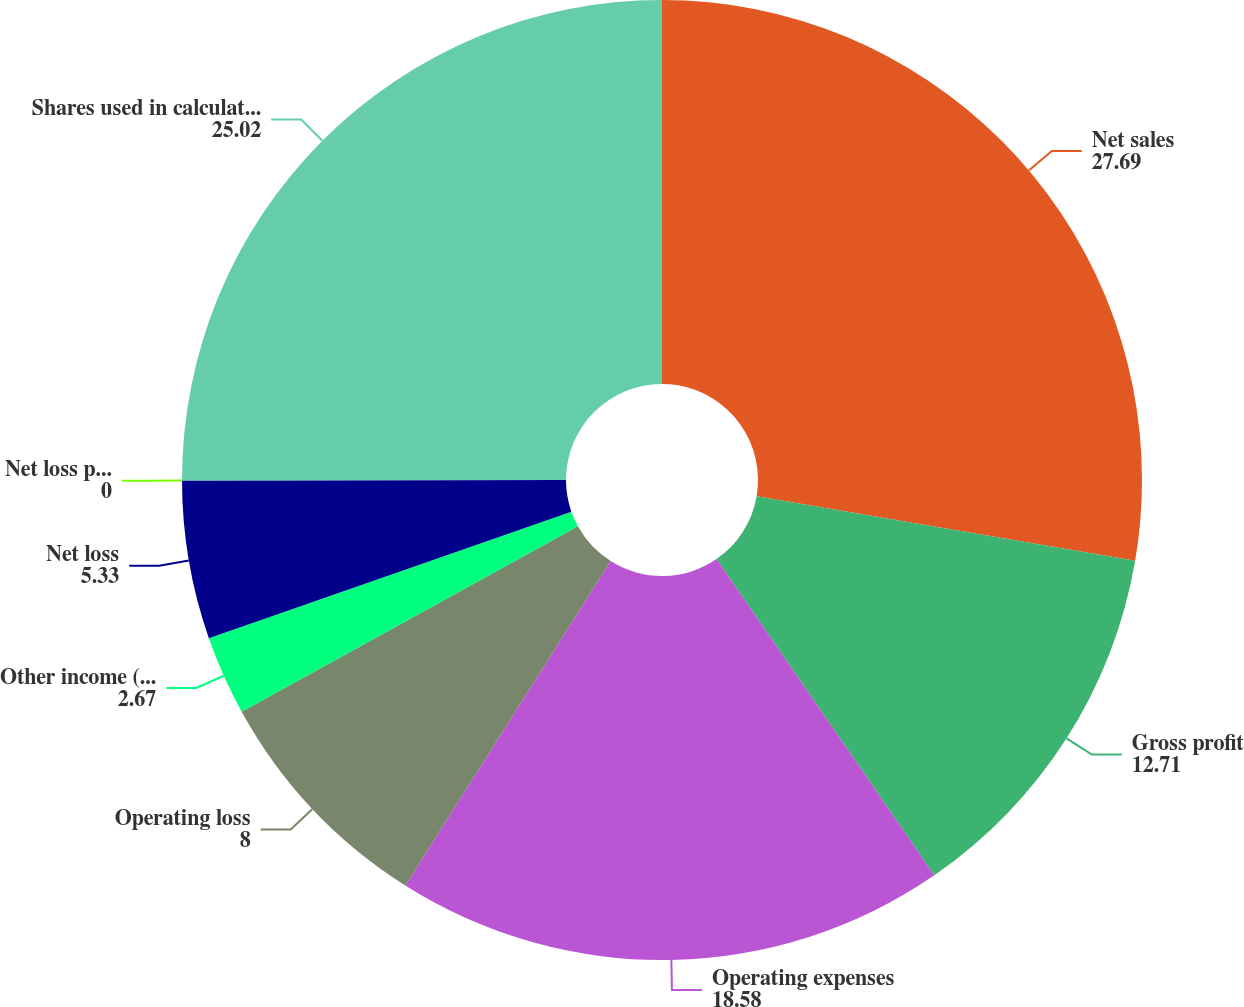<chart> <loc_0><loc_0><loc_500><loc_500><pie_chart><fcel>Net sales<fcel>Gross profit<fcel>Operating expenses<fcel>Operating loss<fcel>Other income (expense)<fcel>Net loss<fcel>Net loss per share<fcel>Shares used in calculation of<nl><fcel>27.69%<fcel>12.71%<fcel>18.58%<fcel>8.0%<fcel>2.67%<fcel>5.33%<fcel>0.0%<fcel>25.02%<nl></chart> 